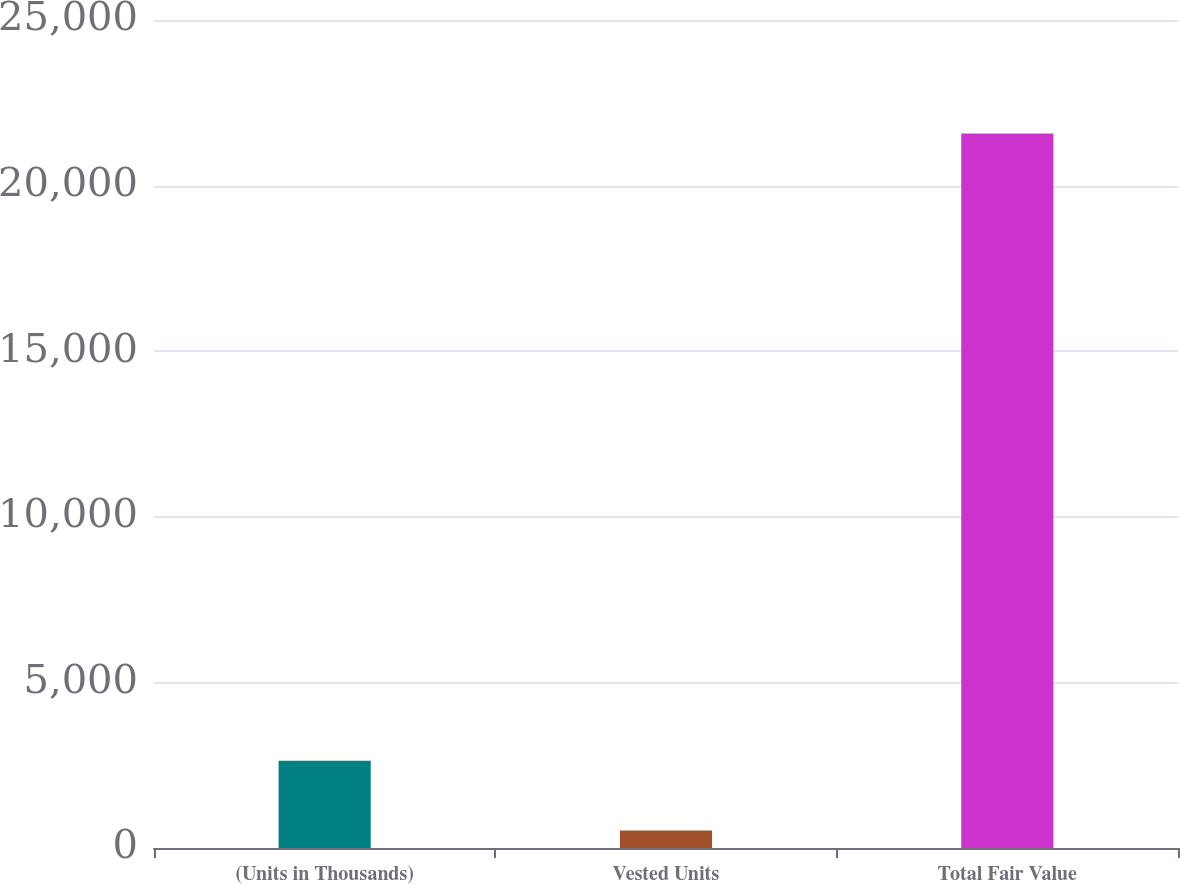Convert chart to OTSL. <chart><loc_0><loc_0><loc_500><loc_500><bar_chart><fcel>(Units in Thousands)<fcel>Vested Units<fcel>Total Fair Value<nl><fcel>2634.5<fcel>530<fcel>21575<nl></chart> 